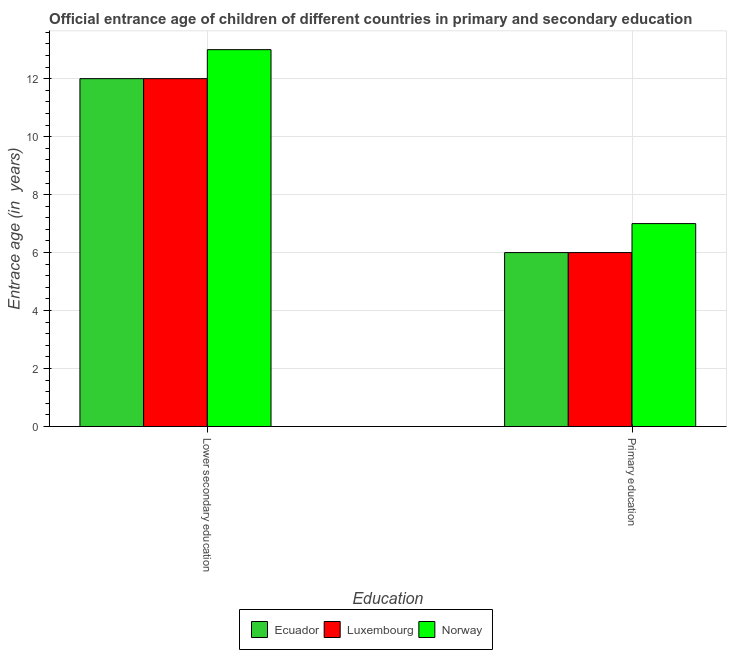How many bars are there on the 2nd tick from the left?
Give a very brief answer. 3. How many bars are there on the 2nd tick from the right?
Your response must be concise. 3. What is the entrance age of children in lower secondary education in Ecuador?
Keep it short and to the point. 12. Across all countries, what is the maximum entrance age of children in lower secondary education?
Give a very brief answer. 13. Across all countries, what is the minimum entrance age of children in lower secondary education?
Offer a terse response. 12. In which country was the entrance age of children in lower secondary education maximum?
Provide a succinct answer. Norway. In which country was the entrance age of children in lower secondary education minimum?
Your answer should be very brief. Ecuador. What is the total entrance age of chiildren in primary education in the graph?
Offer a very short reply. 19. What is the difference between the entrance age of children in lower secondary education in Luxembourg and that in Norway?
Offer a terse response. -1. What is the difference between the entrance age of chiildren in primary education in Luxembourg and the entrance age of children in lower secondary education in Norway?
Make the answer very short. -7. What is the average entrance age of children in lower secondary education per country?
Offer a very short reply. 12.33. What is the difference between the entrance age of children in lower secondary education and entrance age of chiildren in primary education in Luxembourg?
Provide a succinct answer. 6. Is the entrance age of children in lower secondary education in Norway less than that in Ecuador?
Make the answer very short. No. In how many countries, is the entrance age of chiildren in primary education greater than the average entrance age of chiildren in primary education taken over all countries?
Your answer should be compact. 1. What does the 1st bar from the left in Lower secondary education represents?
Provide a short and direct response. Ecuador. How many bars are there?
Your response must be concise. 6. Are all the bars in the graph horizontal?
Give a very brief answer. No. Are the values on the major ticks of Y-axis written in scientific E-notation?
Your answer should be compact. No. Does the graph contain any zero values?
Ensure brevity in your answer.  No. What is the title of the graph?
Your answer should be compact. Official entrance age of children of different countries in primary and secondary education. What is the label or title of the X-axis?
Keep it short and to the point. Education. What is the label or title of the Y-axis?
Offer a terse response. Entrace age (in  years). What is the Entrace age (in  years) of Ecuador in Primary education?
Offer a very short reply. 6. Across all Education, what is the maximum Entrace age (in  years) in Luxembourg?
Make the answer very short. 12. Across all Education, what is the maximum Entrace age (in  years) in Norway?
Your answer should be very brief. 13. Across all Education, what is the minimum Entrace age (in  years) of Luxembourg?
Provide a short and direct response. 6. Across all Education, what is the minimum Entrace age (in  years) of Norway?
Make the answer very short. 7. What is the difference between the Entrace age (in  years) in Ecuador in Lower secondary education and the Entrace age (in  years) in Norway in Primary education?
Make the answer very short. 5. What is the average Entrace age (in  years) in Luxembourg per Education?
Keep it short and to the point. 9. What is the difference between the Entrace age (in  years) in Ecuador and Entrace age (in  years) in Norway in Lower secondary education?
Offer a terse response. -1. What is the difference between the Entrace age (in  years) in Ecuador and Entrace age (in  years) in Luxembourg in Primary education?
Provide a short and direct response. 0. What is the difference between the Entrace age (in  years) of Luxembourg and Entrace age (in  years) of Norway in Primary education?
Your response must be concise. -1. What is the ratio of the Entrace age (in  years) of Ecuador in Lower secondary education to that in Primary education?
Offer a terse response. 2. What is the ratio of the Entrace age (in  years) of Luxembourg in Lower secondary education to that in Primary education?
Your answer should be very brief. 2. What is the ratio of the Entrace age (in  years) of Norway in Lower secondary education to that in Primary education?
Your answer should be compact. 1.86. What is the difference between the highest and the second highest Entrace age (in  years) in Norway?
Give a very brief answer. 6. What is the difference between the highest and the lowest Entrace age (in  years) of Ecuador?
Offer a terse response. 6. 